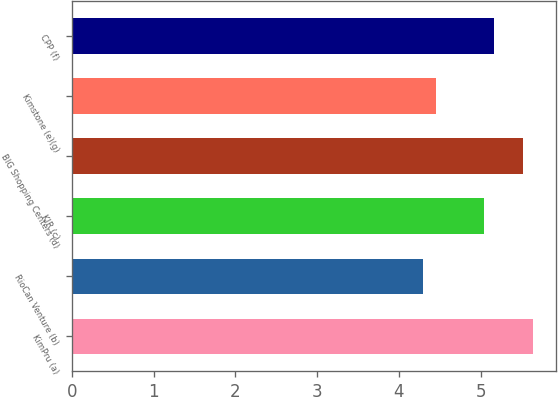Convert chart to OTSL. <chart><loc_0><loc_0><loc_500><loc_500><bar_chart><fcel>KimPru (a)<fcel>RioCan Venture (b)<fcel>KIR (c)<fcel>BIG Shopping Centers (d)<fcel>Kimstone (e)(g)<fcel>CPP (f)<nl><fcel>5.64<fcel>4.29<fcel>5.04<fcel>5.52<fcel>4.45<fcel>5.16<nl></chart> 